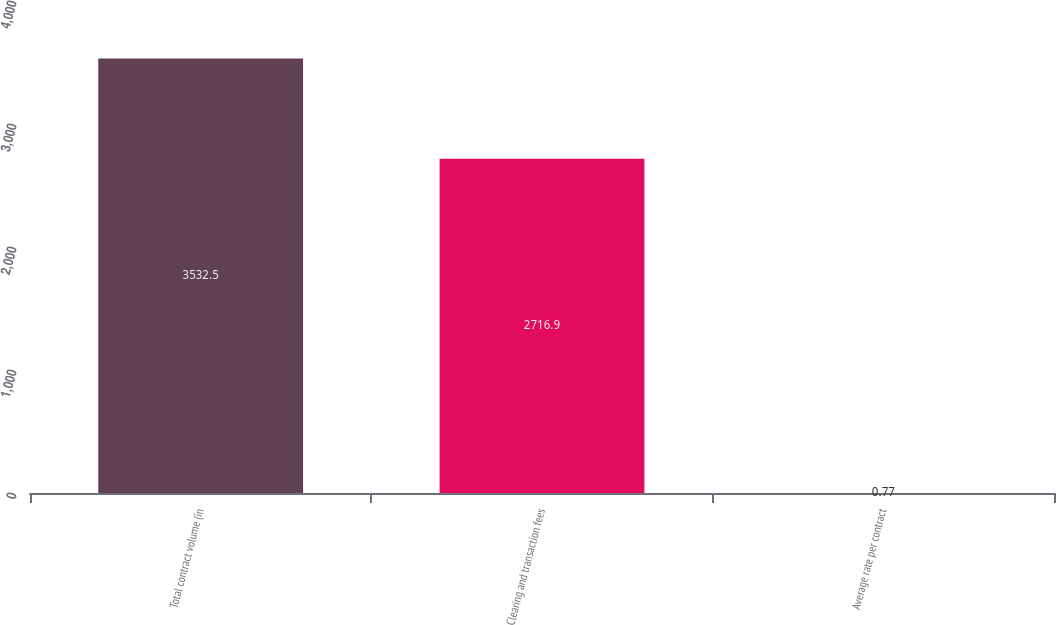Convert chart. <chart><loc_0><loc_0><loc_500><loc_500><bar_chart><fcel>Total contract volume (in<fcel>Clearing and transaction fees<fcel>Average rate per contract<nl><fcel>3532.5<fcel>2716.9<fcel>0.77<nl></chart> 